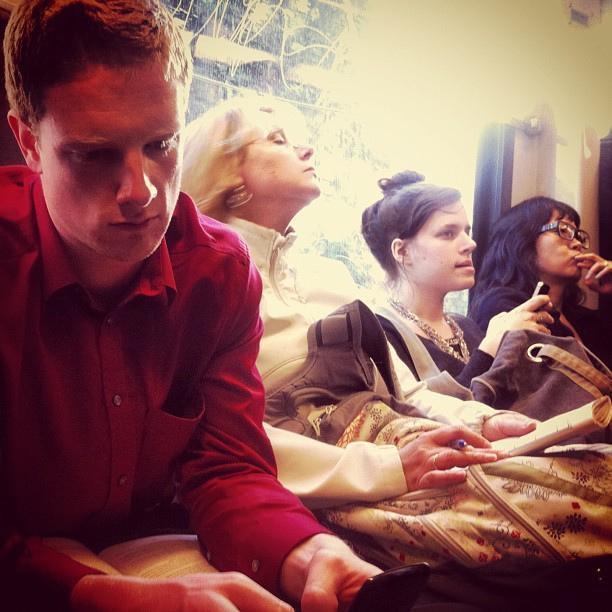The expression on the people's faces reveal that the bus is what?
Indicate the correct choice and explain in the format: 'Answer: answer
Rationale: rationale.'
Options: Fun, unpleasant, pleasant, scary. Answer: unpleasant.
Rationale: People sit in a line together, all with negative expressions on their faces. 